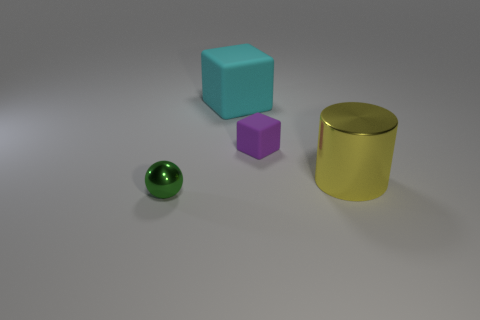Does the small green ball have the same material as the tiny thing on the right side of the small green shiny ball?
Offer a terse response. No. Is the number of big cylinders less than the number of gray shiny blocks?
Provide a succinct answer. No. Is there any other thing of the same color as the large metal cylinder?
Offer a very short reply. No. There is a tiny purple object that is the same material as the big cyan cube; what is its shape?
Make the answer very short. Cube. What number of large cyan blocks are behind the big object behind the metallic thing that is right of the green metallic ball?
Your answer should be very brief. 0. What shape is the thing that is both behind the small green ball and in front of the purple object?
Offer a very short reply. Cylinder. Is the number of large cyan matte objects that are in front of the tiny purple rubber object less than the number of purple metallic blocks?
Make the answer very short. No. What number of large things are metallic balls or brown cylinders?
Your response must be concise. 0. What size is the cylinder?
Provide a succinct answer. Large. Is there any other thing that is made of the same material as the green ball?
Your answer should be very brief. Yes. 